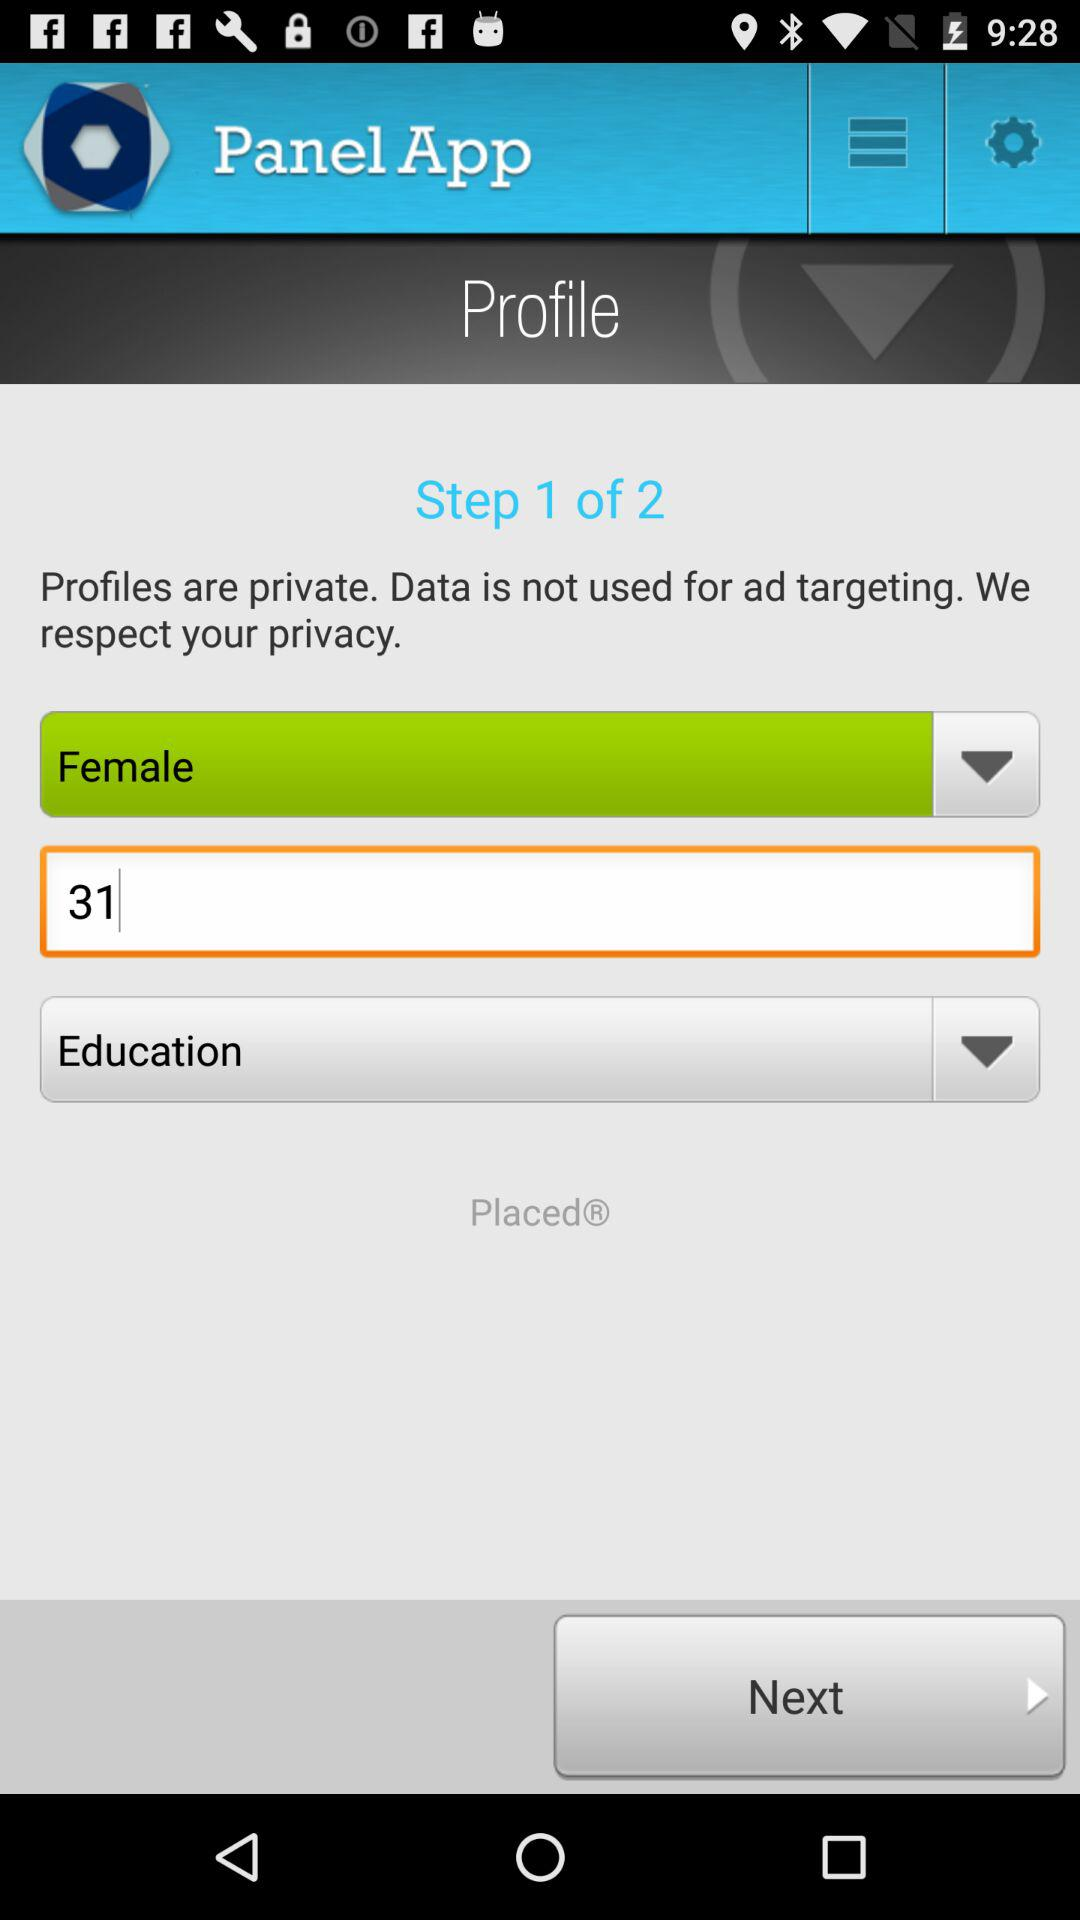Which gender is selected? The selected gender is "Female". 